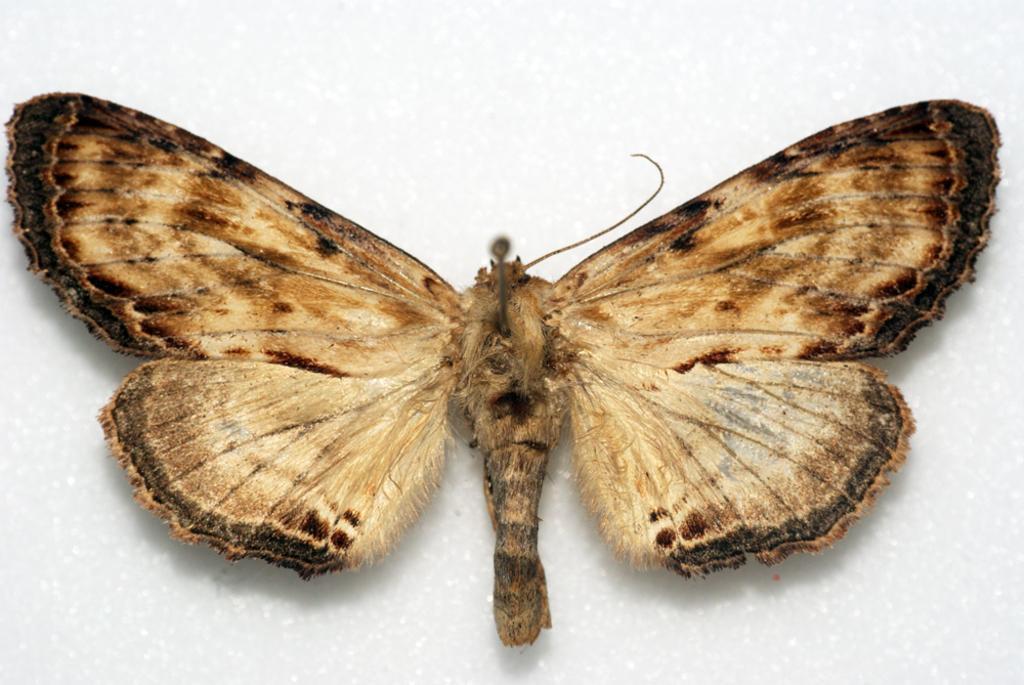In one or two sentences, can you explain what this image depicts? In this image we can see a butterfly on the white color surface. 